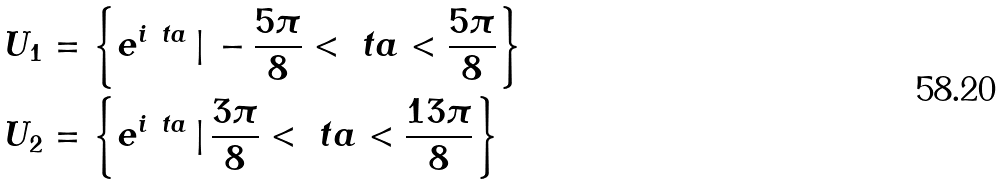Convert formula to latex. <formula><loc_0><loc_0><loc_500><loc_500>U _ { 1 } & = \left \{ e ^ { i \ t a } \, | \, - \frac { 5 \pi } { 8 } < \ t a < \frac { 5 \pi } { 8 } \right \} \\ U _ { 2 } & = \left \{ e ^ { i \ t a } \, | \, \frac { 3 \pi } { 8 } < \ t a < \frac { 1 3 \pi } { 8 } \right \}</formula> 